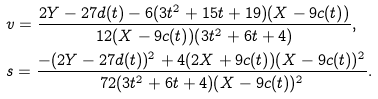Convert formula to latex. <formula><loc_0><loc_0><loc_500><loc_500>& v = \frac { 2 Y - 2 7 d ( t ) - 6 ( 3 t ^ { 2 } + 1 5 t + 1 9 ) ( X - 9 c ( t ) ) } { 1 2 ( X - 9 c ( t ) ) ( 3 t ^ { 2 } + 6 t + 4 ) } , \\ & s = \frac { - ( 2 Y - 2 7 d ( t ) ) ^ { 2 } + 4 ( 2 X + 9 c ( t ) ) ( X - 9 c ( t ) ) ^ { 2 } } { 7 2 ( 3 t ^ { 2 } + 6 t + 4 ) ( X - 9 c ( t ) ) ^ { 2 } } .</formula> 